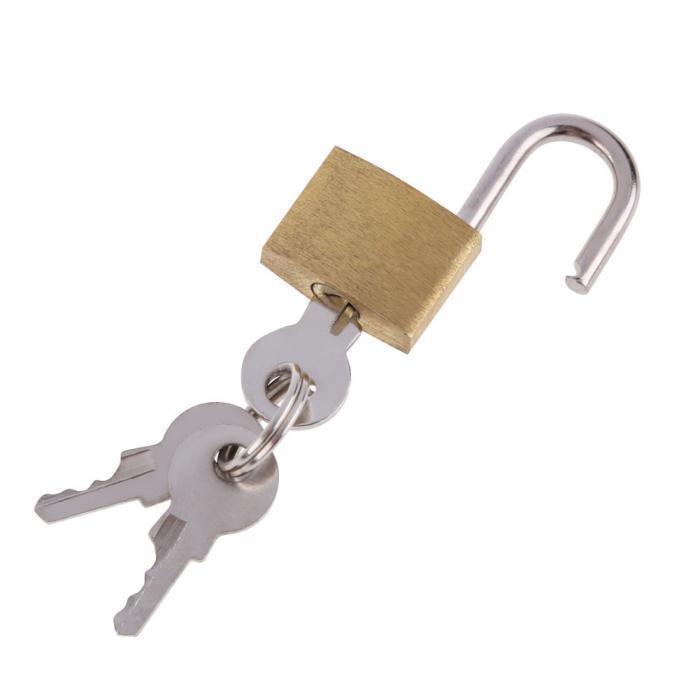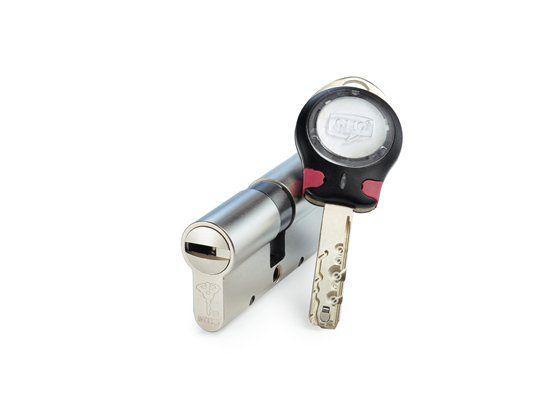The first image is the image on the left, the second image is the image on the right. Analyze the images presented: Is the assertion "The left image shows a lock with a key on a keychain inserted." valid? Answer yes or no. Yes. 